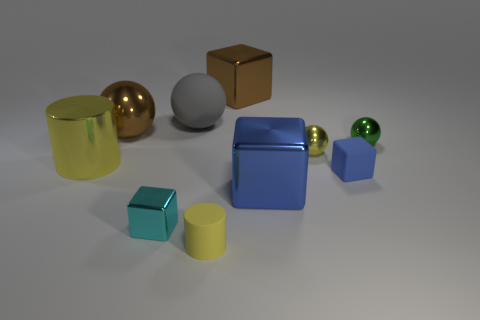Subtract 1 blocks. How many blocks are left? 3 Subtract all balls. How many objects are left? 6 Subtract all small gray matte spheres. Subtract all tiny rubber cubes. How many objects are left? 9 Add 9 tiny green balls. How many tiny green balls are left? 10 Add 2 big blue metal things. How many big blue metal things exist? 3 Subtract 0 blue cylinders. How many objects are left? 10 